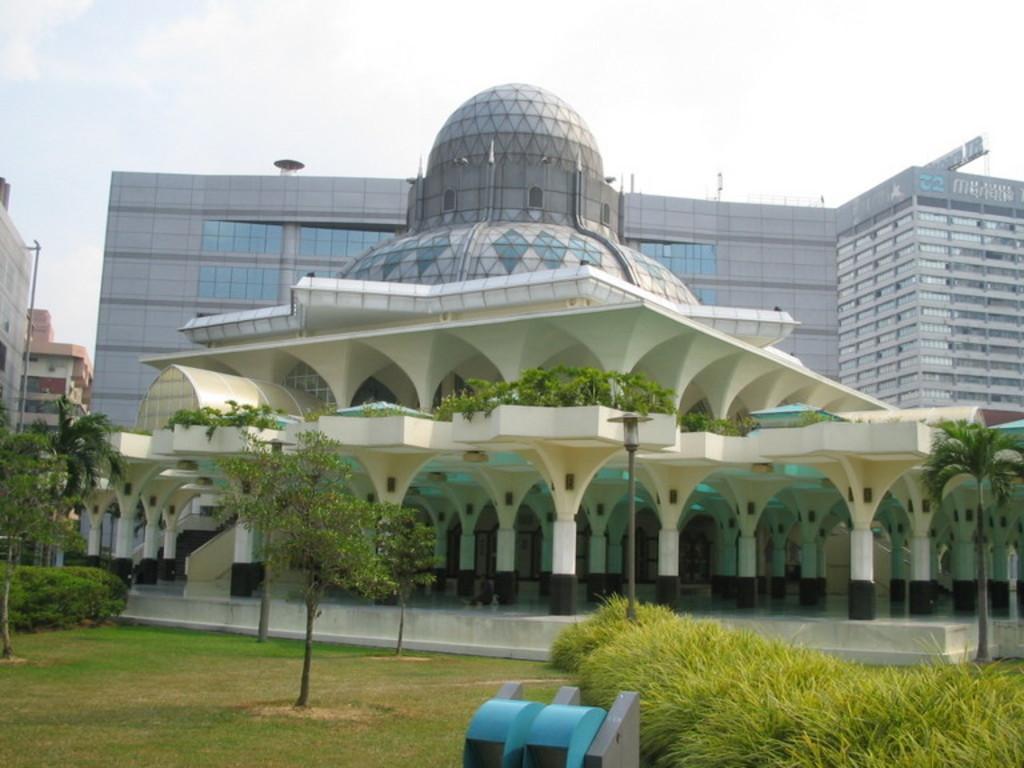What type of structure is present in the image? There is a building in the image. Can you describe any specific features of the building? The building has a dome on top. What type of vegetation can be seen in the image? There are plants and trees in the image. What is visible in the background of the image? The sky is visible in the background of the image. How many crows are sitting on the dome of the building in the image? There are no crows present in the image; the building has a dome, but no crows are visible. What type of health advice can be found in the image? There is no health advice present in the image; it features a building with a dome and surrounding vegetation. 